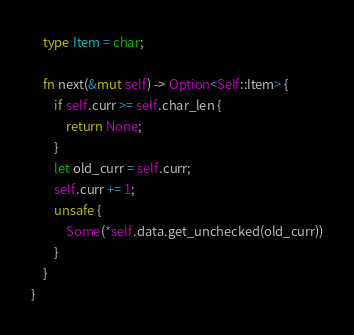Convert code to text. <code><loc_0><loc_0><loc_500><loc_500><_Rust_>    type Item = char;

    fn next(&mut self) -> Option<Self::Item> {
        if self.curr >= self.char_len {
            return None;
        }
        let old_curr = self.curr;
        self.curr += 1;
        unsafe {
            Some(*self.data.get_unchecked(old_curr))
        }
    }
}</code> 